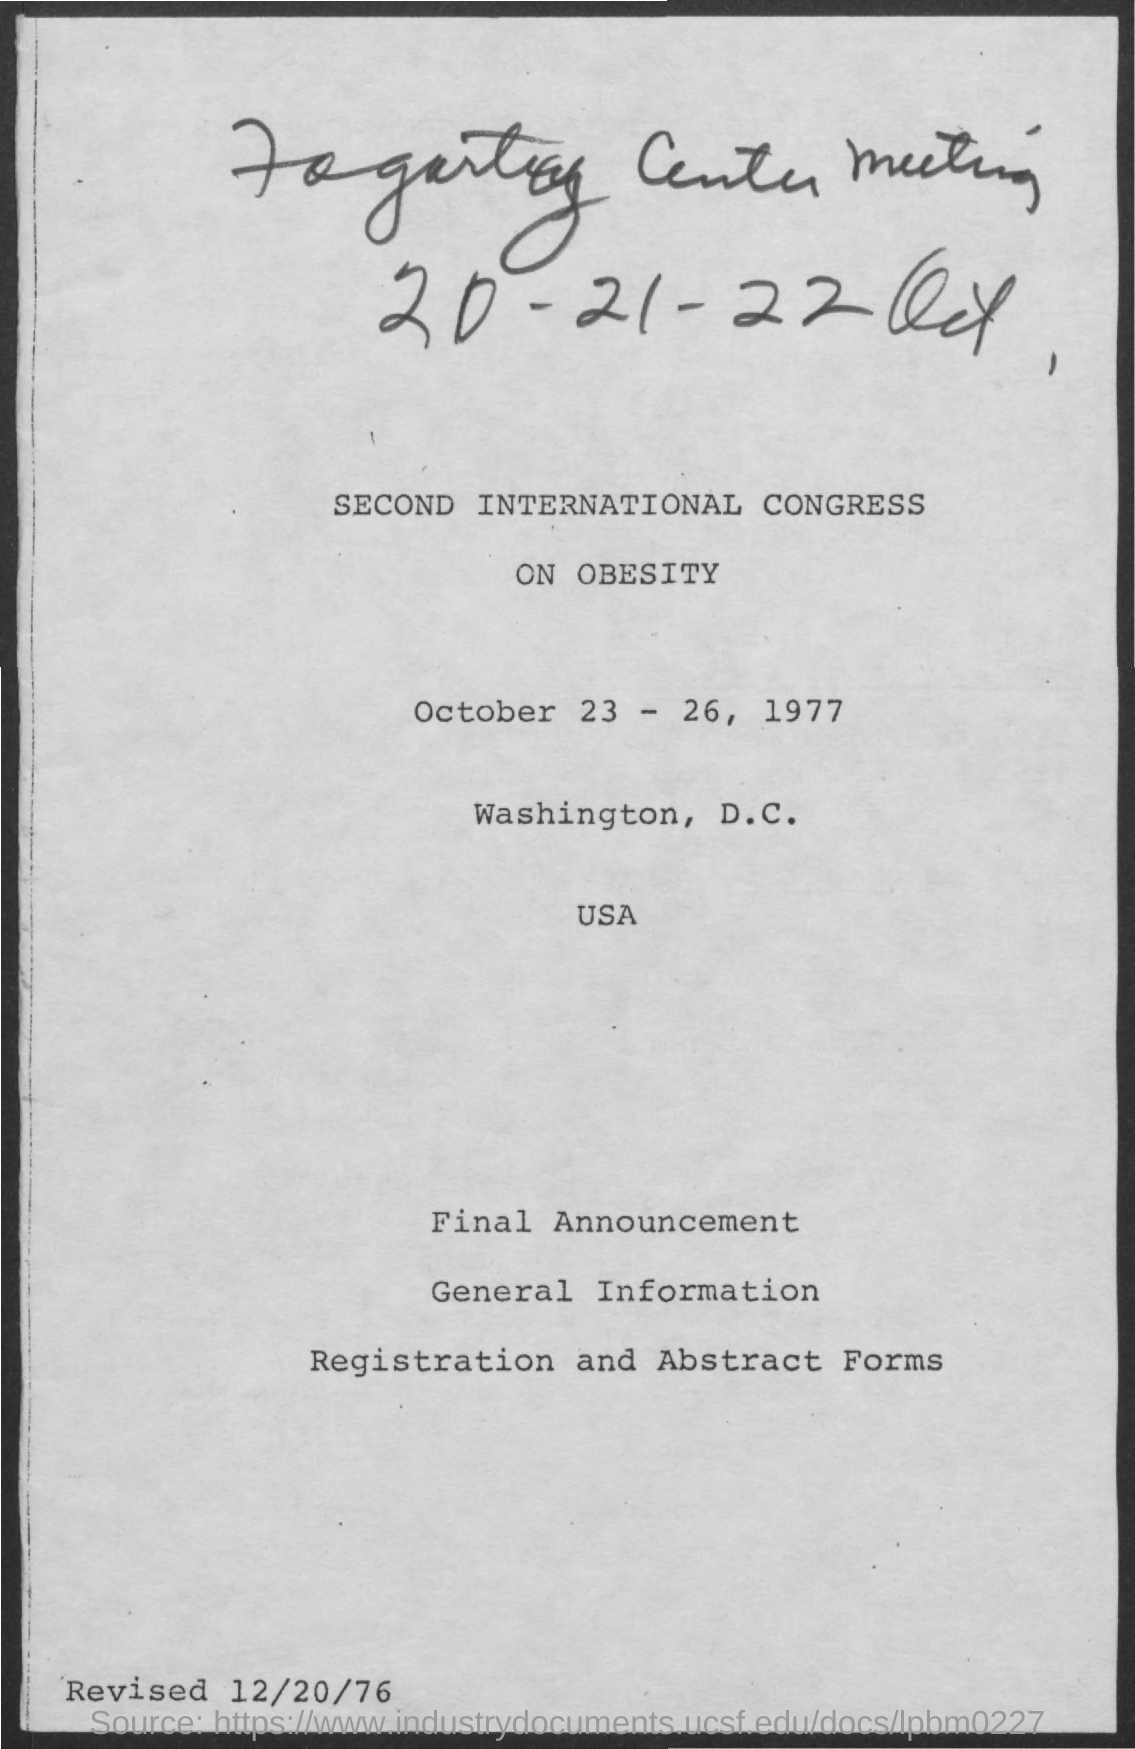Draw attention to some important aspects in this diagram. The international congress was conducted in the United States of America. 